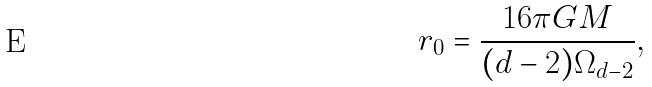<formula> <loc_0><loc_0><loc_500><loc_500>r _ { 0 } = \frac { 1 6 \pi G M } { ( d - 2 ) \Omega _ { d - 2 } } ,</formula> 